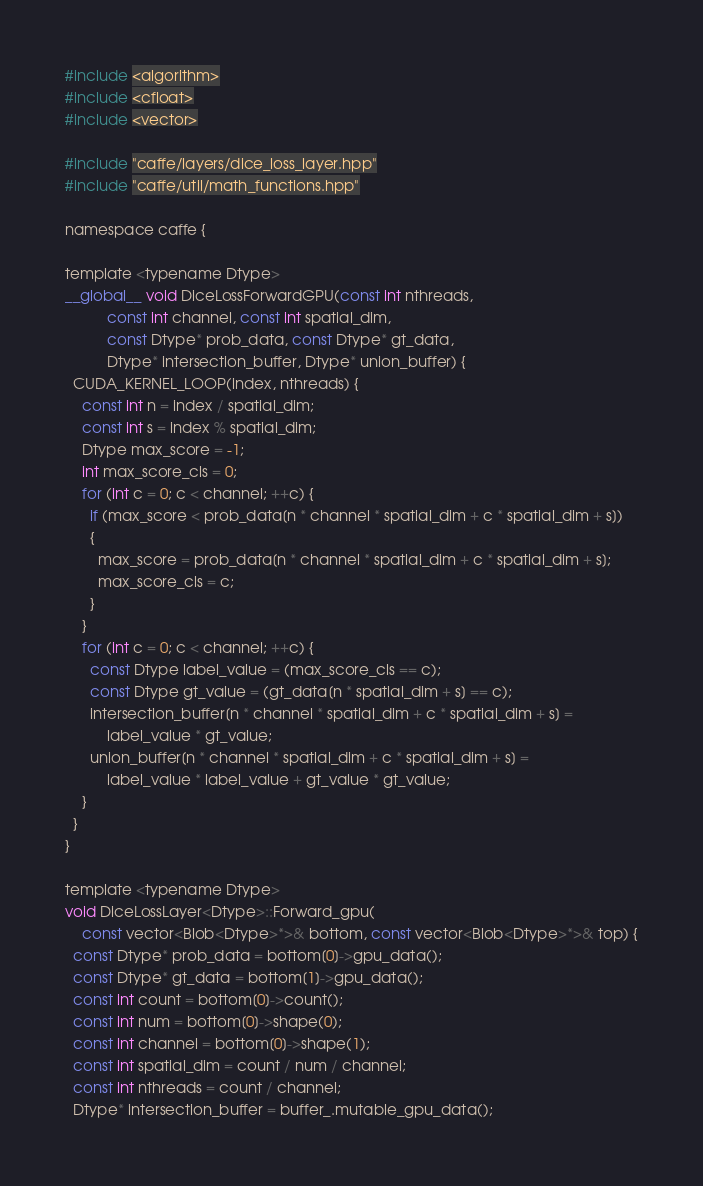<code> <loc_0><loc_0><loc_500><loc_500><_Cuda_>#include <algorithm>
#include <cfloat>
#include <vector>

#include "caffe/layers/dice_loss_layer.hpp"
#include "caffe/util/math_functions.hpp"

namespace caffe {

template <typename Dtype>
__global__ void DiceLossForwardGPU(const int nthreads, 
	      const int channel, const int spatial_dim, 
          const Dtype* prob_data, const Dtype* gt_data, 
		  Dtype* intersection_buffer, Dtype* union_buffer) {
  CUDA_KERNEL_LOOP(index, nthreads) {
    const int n = index / spatial_dim;
	const int s = index % spatial_dim;
	Dtype max_score = -1;
	int max_score_cls = 0;
    for (int c = 0; c < channel; ++c) {
      if (max_score < prob_data[n * channel * spatial_dim + c * spatial_dim + s])
      {
        max_score = prob_data[n * channel * spatial_dim + c * spatial_dim + s];
        max_score_cls = c;
      }
    }
    for (int c = 0; c < channel; ++c) {
	  const Dtype label_value = (max_score_cls == c);
	  const Dtype gt_value = (gt_data[n * spatial_dim + s] == c);
	  intersection_buffer[n * channel * spatial_dim + c * spatial_dim + s] = 
		  label_value * gt_value;
	  union_buffer[n * channel * spatial_dim + c * spatial_dim + s] = 
		  label_value * label_value + gt_value * gt_value;
    }
  }
}

template <typename Dtype>
void DiceLossLayer<Dtype>::Forward_gpu(
    const vector<Blob<Dtype>*>& bottom, const vector<Blob<Dtype>*>& top) {
  const Dtype* prob_data = bottom[0]->gpu_data();
  const Dtype* gt_data = bottom[1]->gpu_data();
  const int count = bottom[0]->count();
  const int num = bottom[0]->shape(0);
  const int channel = bottom[0]->shape(1);
  const int spatial_dim = count / num / channel;
  const int nthreads = count / channel;
  Dtype* intersection_buffer = buffer_.mutable_gpu_data();</code> 